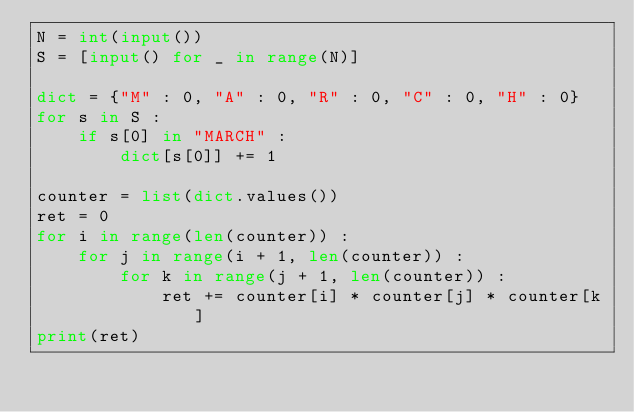Convert code to text. <code><loc_0><loc_0><loc_500><loc_500><_Python_>N = int(input())
S = [input() for _ in range(N)]

dict = {"M" : 0, "A" : 0, "R" : 0, "C" : 0, "H" : 0}
for s in S :
    if s[0] in "MARCH" :
        dict[s[0]] += 1

counter = list(dict.values())
ret = 0
for i in range(len(counter)) :
    for j in range(i + 1, len(counter)) :
        for k in range(j + 1, len(counter)) :
            ret += counter[i] * counter[j] * counter[k]
print(ret)</code> 